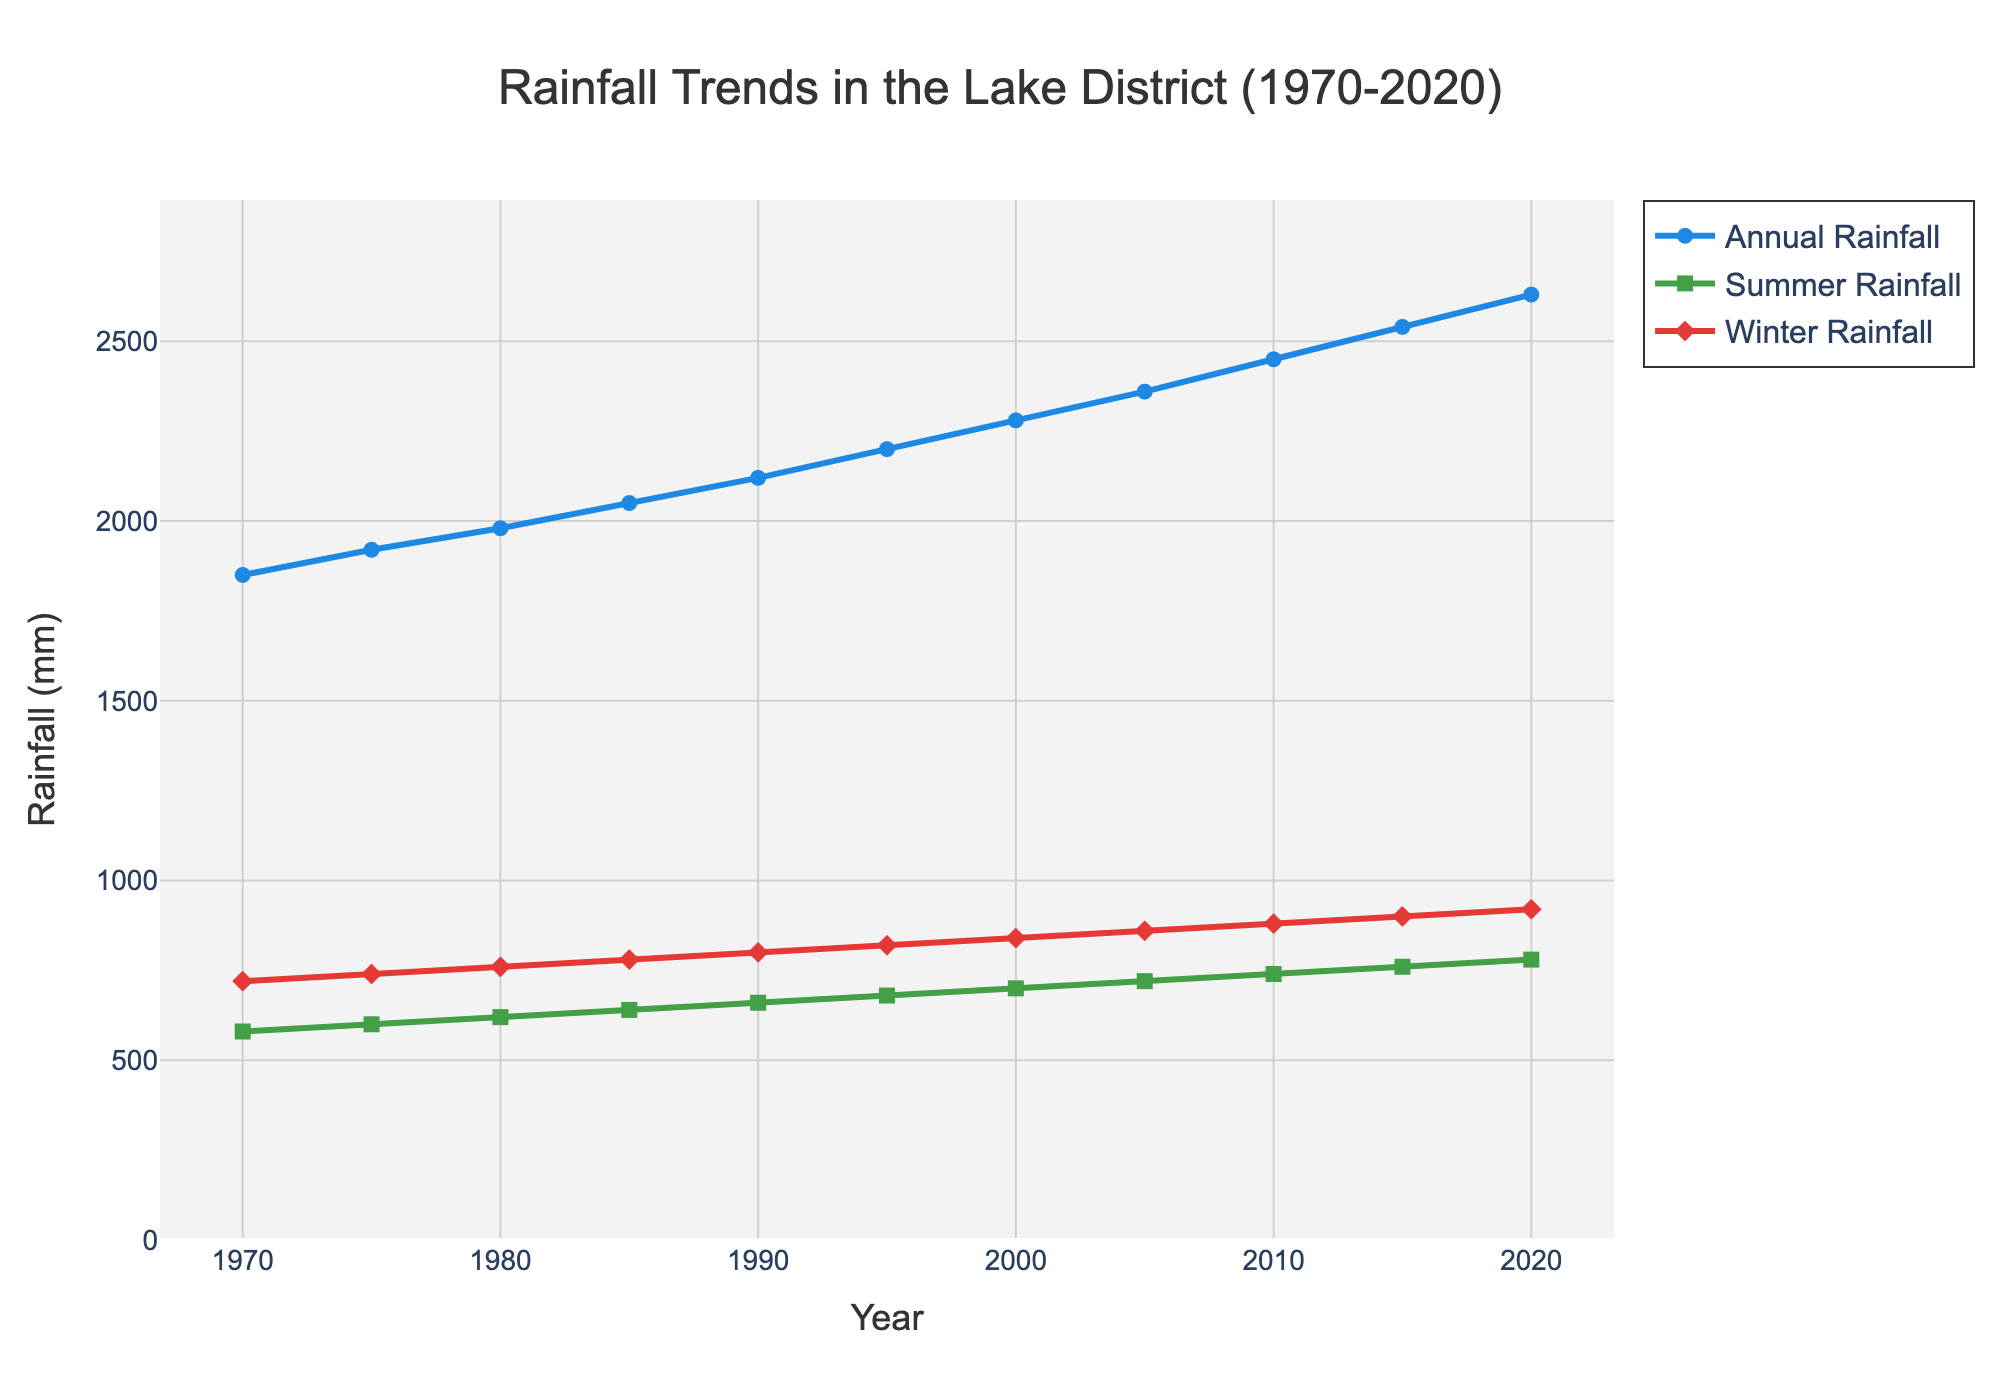What is the trend in annual rainfall from 1970 to 2020? The annual rainfall shows an increasing trend over the five decades, starting at 1850 mm in 1970 and reaching 2630 mm by 2020.
Answer: Increasing Which year has the highest summer rainfall? By checking each year's summer rainfall values, we find that 2020 has the highest summer rainfall at 780 mm.
Answer: 2020 What is the difference in winter rainfall between 1970 and 2020? The winter rainfall in 1970 is 720 mm and in 2020 is 920 mm. The difference is 920 mm - 720 mm.
Answer: 200 mm How much did the annual rainfall increase from 1980 to 2000? Annual rainfall in 1980 is 1980 mm and in 2000 is 2280 mm. The increase is 2280 mm - 1980 mm.
Answer: 300 mm Which season's rainfall shows the steeper increase over the years, summer or winter? By comparing the slopes of the lines representing summer and winter rainfall, the winter rainfall line seems steeper, indicating a greater rate of increase.
Answer: Winter On average, how many rainy days per year were there in the 2010s (2010-2020)? The rainy days per year in 2010, 2015, and 2020 are 240, 245, and 250 respectively. The average is (240 + 245 + 250) / 3.
Answer: 245 Is there a year where the winter rainfall is higher than both the summer and annual rainfall? By visually inspecting the figure, there is no year where winter rainfall surpasses both summer and annual rainfall values.
Answer: No What is the rate of increase in annual rainfall per decade from 1970 to 2020? The annual rainfall in 1970 is 1850 mm and in 2020 is 2630 mm, a 780 mm increase over 50 years. The rate per decade is 780 mm / 5 decades.
Answer: 156 mm per decade How does the number of rainy days change with increasing summer rainfall? By observing the graph, both the number of rainy days and summer rainfall increase steadily over time, indicating a positive correlation.
Answer: Positive correlation What is the total increase in summer rainfall from 1970 to 2020? Summer rainfall in 1970 is 580 mm and in 2020 is 780 mm. The total increase is 780 mm - 580 mm.
Answer: 200 mm 